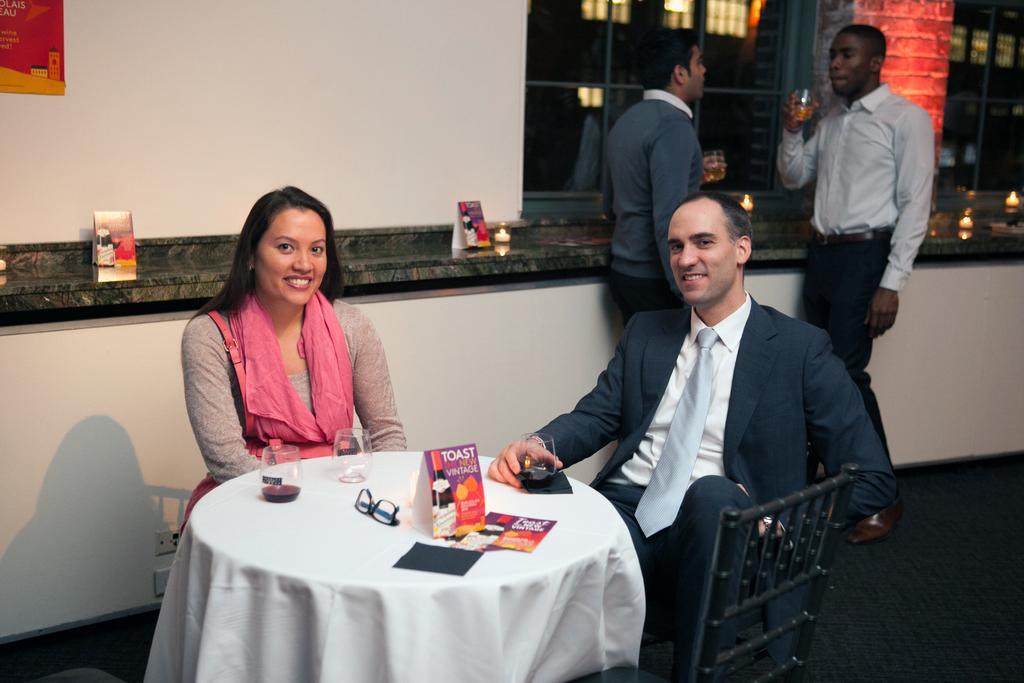Can you describe this image briefly? There is a couple sitting on a chair and they are smiling. This is a table where a glass and a spectacles are kept on it. In the background there are two people standing on the right side and they are having a drink. 